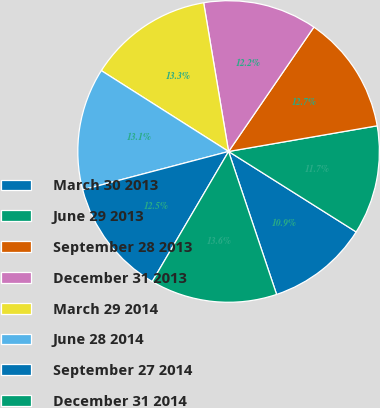Convert chart. <chart><loc_0><loc_0><loc_500><loc_500><pie_chart><fcel>March 30 2013<fcel>June 29 2013<fcel>September 28 2013<fcel>December 31 2013<fcel>March 29 2014<fcel>June 28 2014<fcel>September 27 2014<fcel>December 31 2014<nl><fcel>10.89%<fcel>11.68%<fcel>12.71%<fcel>12.21%<fcel>13.35%<fcel>13.1%<fcel>12.46%<fcel>13.61%<nl></chart> 